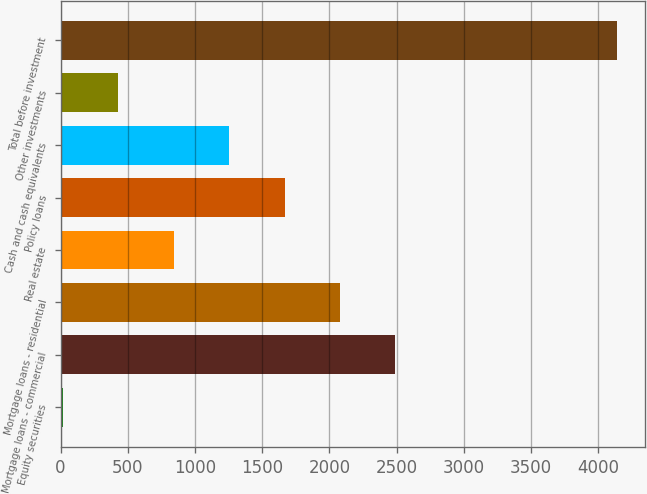Convert chart to OTSL. <chart><loc_0><loc_0><loc_500><loc_500><bar_chart><fcel>Equity securities<fcel>Mortgage loans - commercial<fcel>Mortgage loans - residential<fcel>Real estate<fcel>Policy loans<fcel>Cash and cash equivalents<fcel>Other investments<fcel>Total before investment<nl><fcel>18.9<fcel>2490.36<fcel>2078.45<fcel>842.72<fcel>1666.54<fcel>1254.63<fcel>430.81<fcel>4138<nl></chart> 